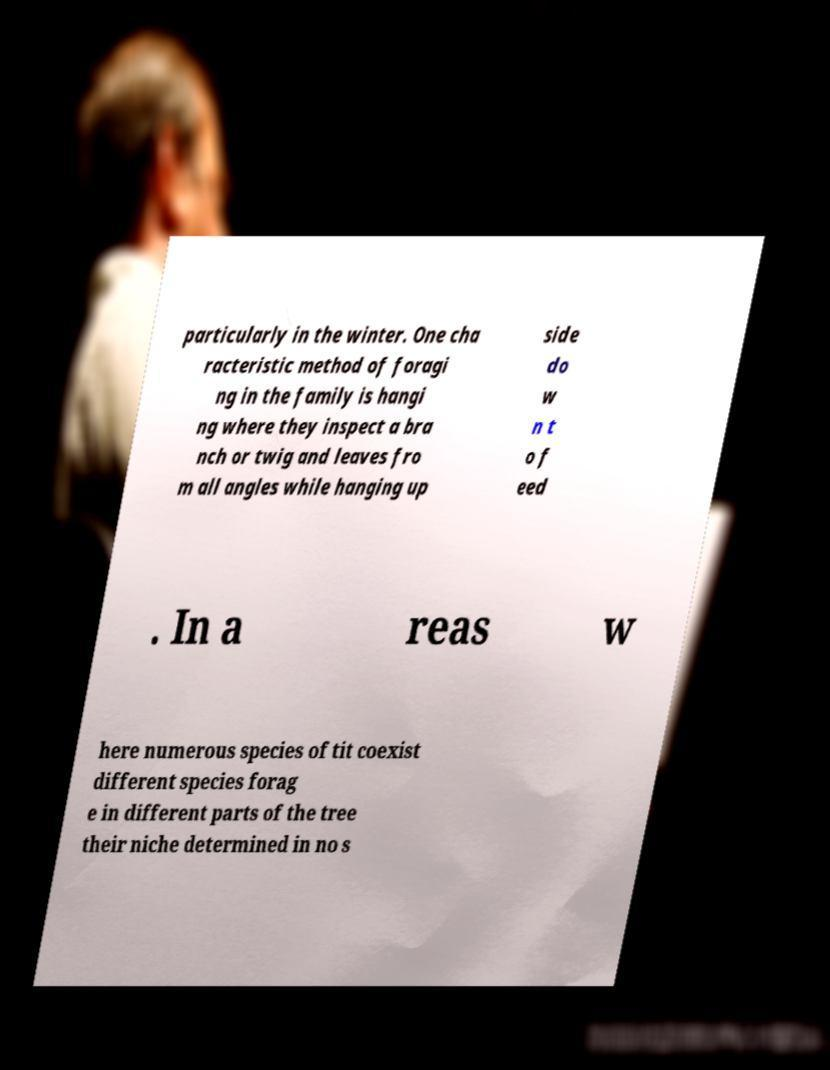What messages or text are displayed in this image? I need them in a readable, typed format. particularly in the winter. One cha racteristic method of foragi ng in the family is hangi ng where they inspect a bra nch or twig and leaves fro m all angles while hanging up side do w n t o f eed . In a reas w here numerous species of tit coexist different species forag e in different parts of the tree their niche determined in no s 